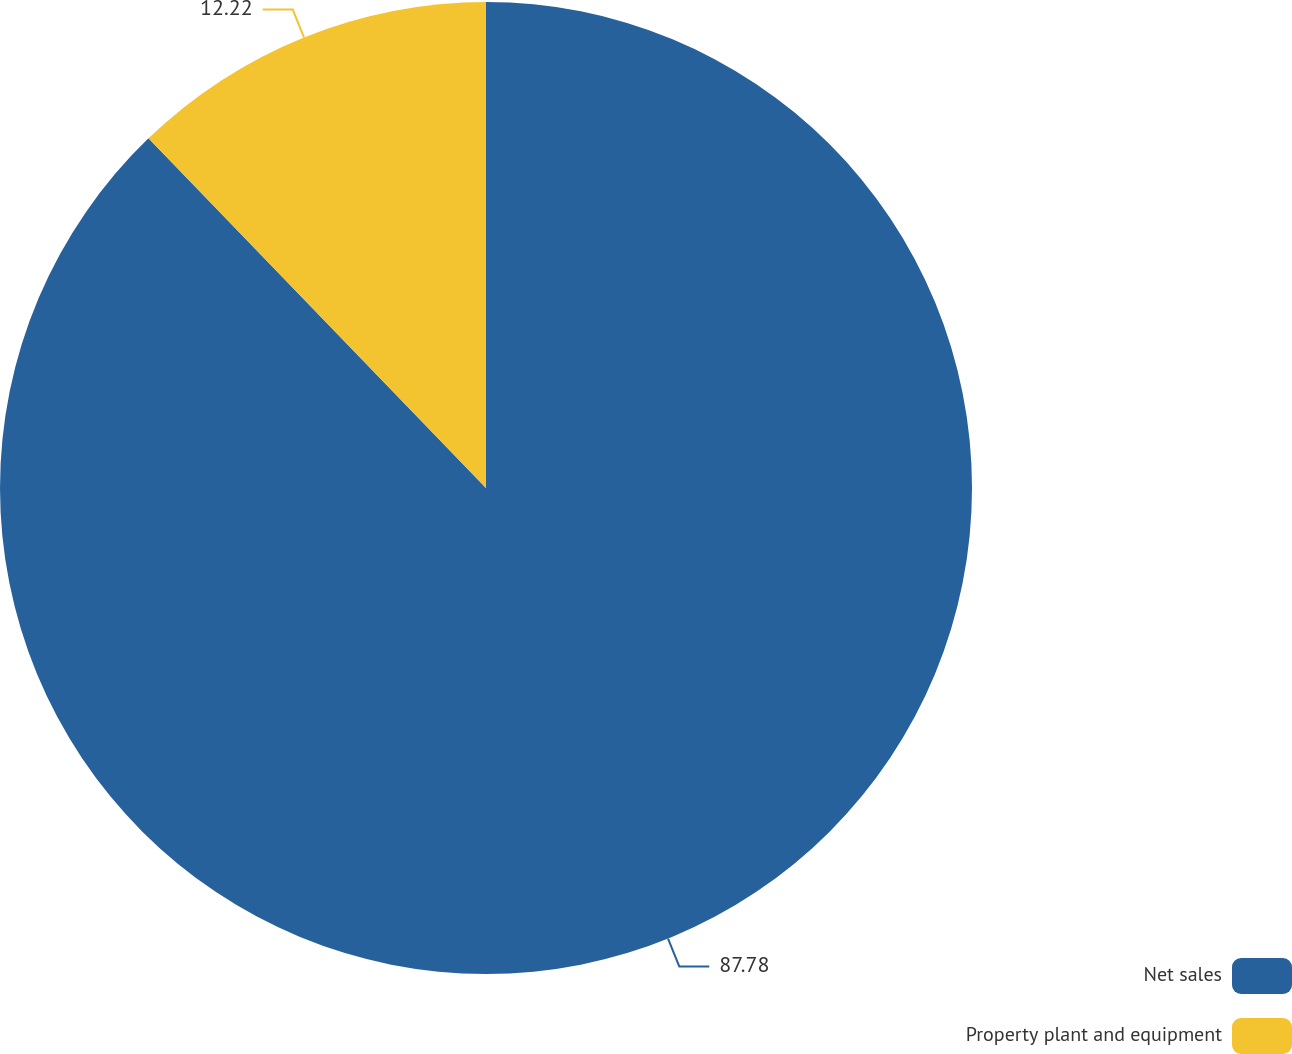Convert chart to OTSL. <chart><loc_0><loc_0><loc_500><loc_500><pie_chart><fcel>Net sales<fcel>Property plant and equipment<nl><fcel>87.78%<fcel>12.22%<nl></chart> 